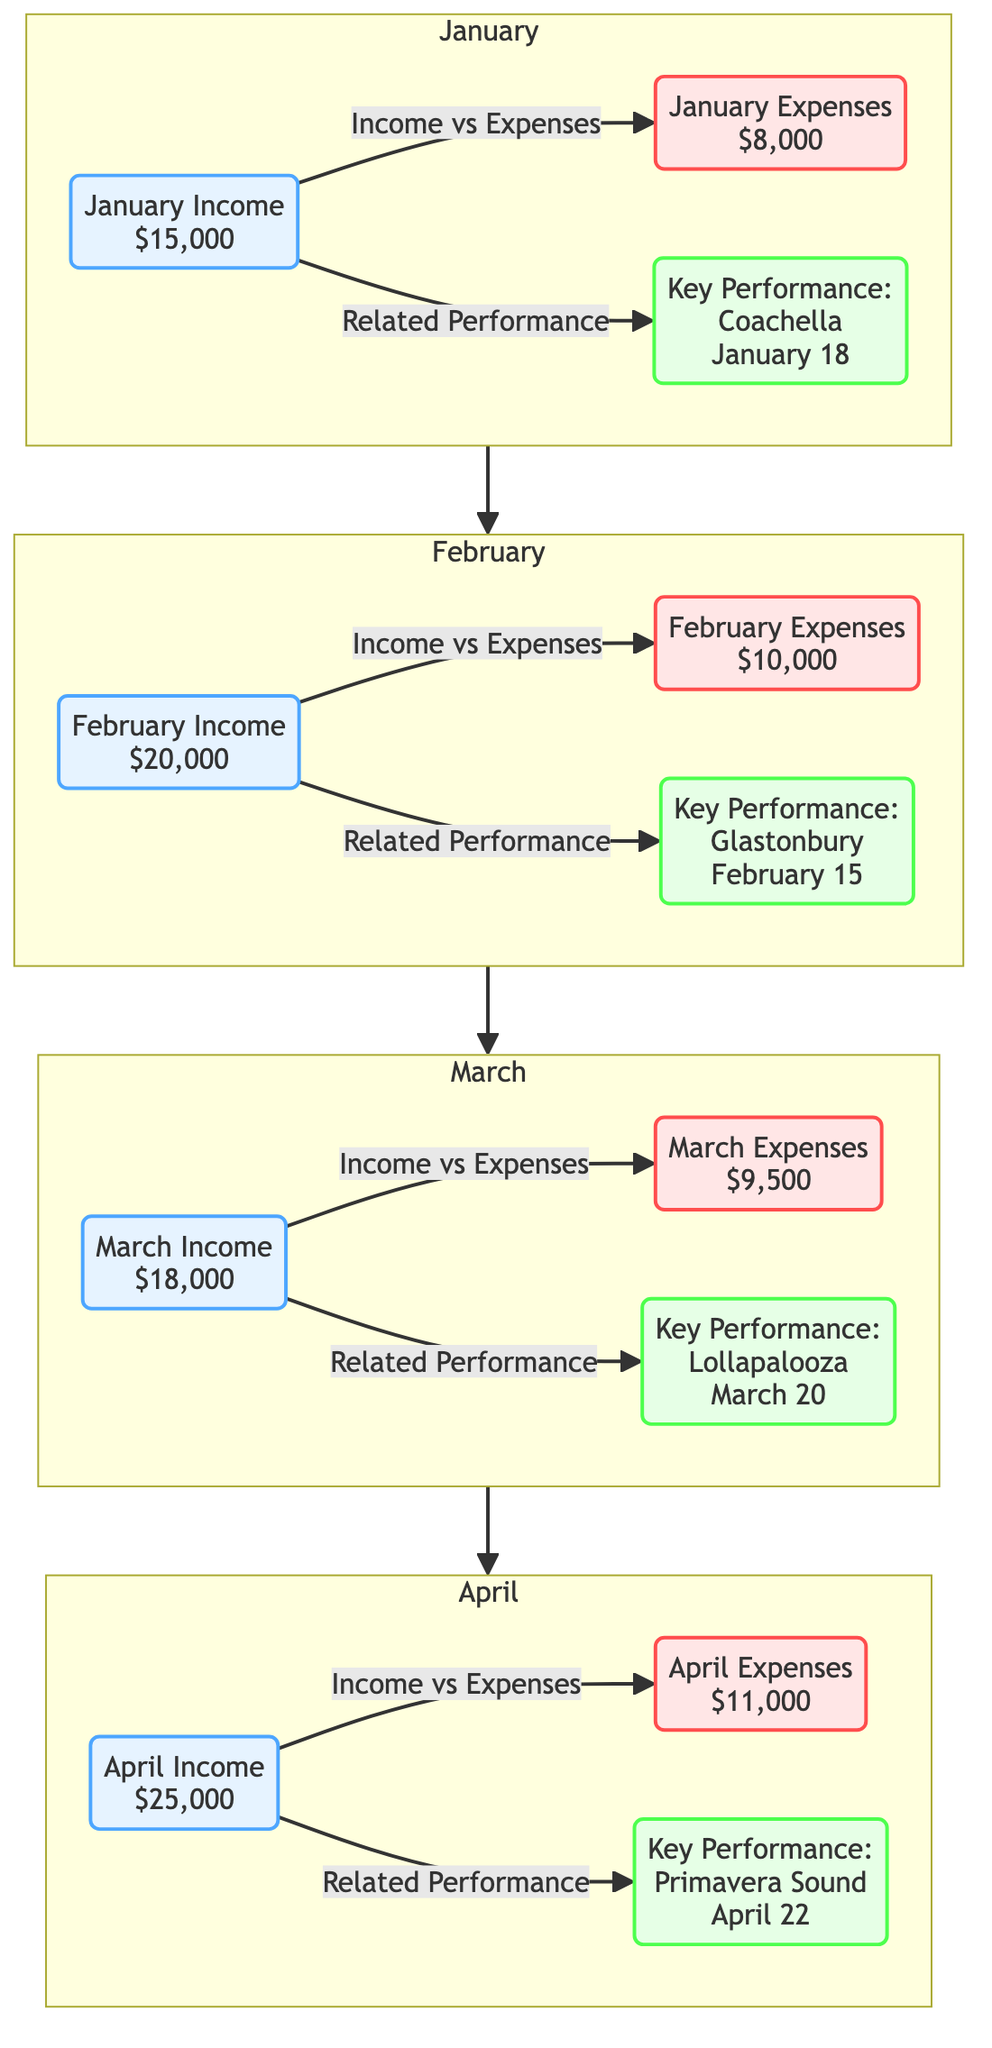What's the income for January? The diagram shows "January Income" followed by the value "$15,000". This is a descriptive aspect of the diagram, directly reflecting the income for that month.
Answer: $15,000 What is the total expenses for February? Referring to the diagram, "February Expenses" shows the value "$10,000". This provides a straightforward visual representation of the monthly expenses.
Answer: $10,000 Which key performance is highlighted for March? The diagram indicates "Key Performance: Lollapalooza" along with the date "March 20". This is clearly stated in the corresponding section for March.
Answer: Lollapalooza What is the income versus expenses comparison for April? The diagram illustrates the flow from "April Income" of "$25,000" to "April Expenses" of "$11,000". The income is greater than expenses by $14,000, which indicates the profitability for that month.
Answer: $25,000 and $11,000 How many months are represented in the diagram? The diagram encompasses the months of January, February, March, and April, making a total of four distinct months, as seen in the subgraph structure.
Answer: 4 What is the average income across the four months? To find the average, we first sum the income values: $15,000 + $20,000 + $18,000 + $25,000 equals $78,000. Then, dividing by the number of months (4) gives $19,500, thus providing an understanding of overall revenue during this period.
Answer: $19,500 How does the expense for March compare with January? In March, the expenses are "$9,500" while in January, they are "$8,000". When comparing these figures, March's expenses are $1,500 higher than those in January, indicating higher expenditure despite lower income levels.
Answer: Higher by $1,500 Which month has the highest income? Analyzing the income values for each month, April has the highest income of "$25,000", compared to January's $15,000, February's $20,000, and March's $18,000.
Answer: April What type of relationships are depicted in the diagram? The relationships illustrated in the diagram show flows indicating links between income, expenses, and performances for each month. These connections outline an important narrative of financial performance and key events.
Answer: Income vs Expenses and Related Performance 